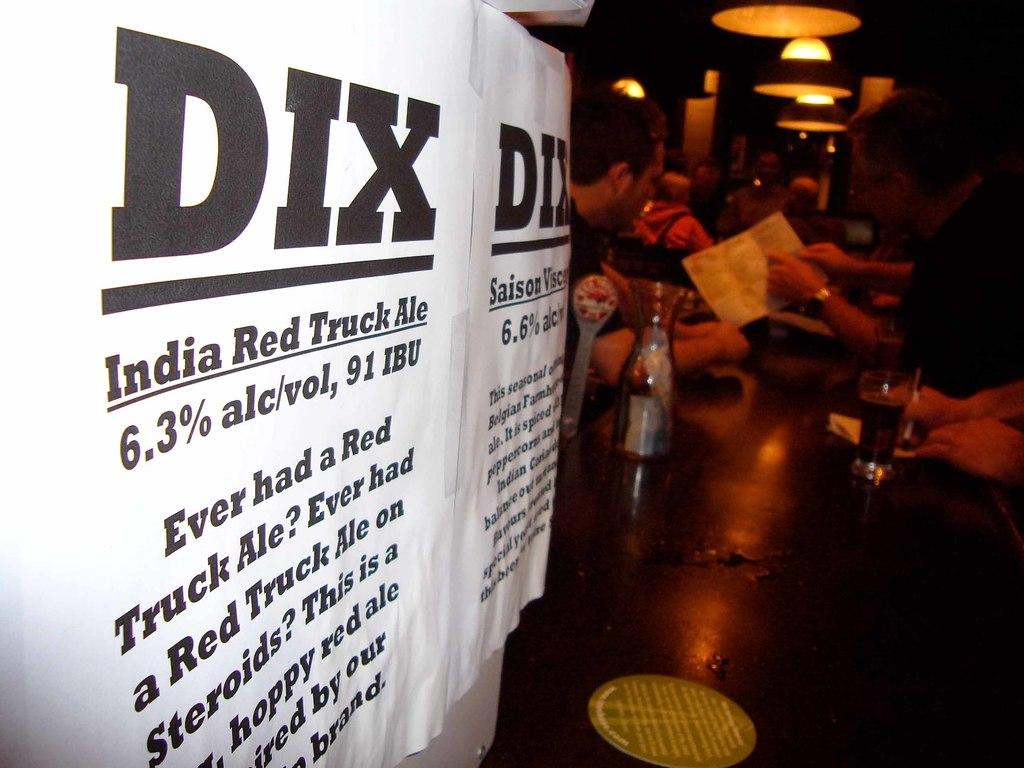Provide a one-sentence caption for the provided image. The type of alcohol listed is called India Red Truck Ale. 